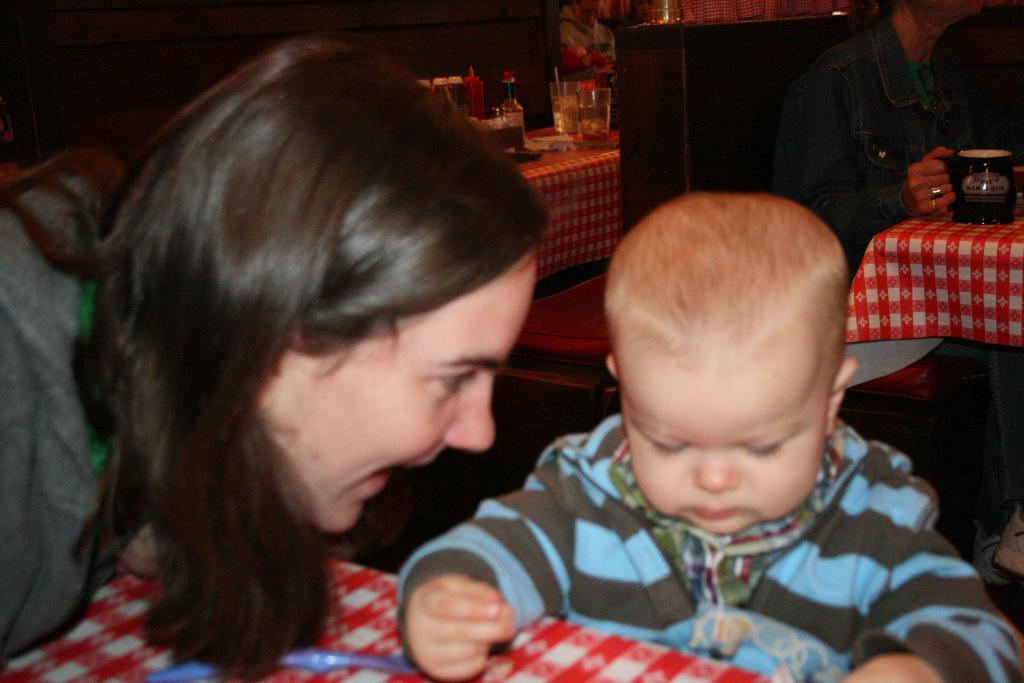In one or two sentences, can you explain what this image depicts? In this image we can see a person near the kid. And we can see there are two persons sitting on the couch and holding cup. There are tables with a cloth, on the table there are glasses, bottles and a few objects. 